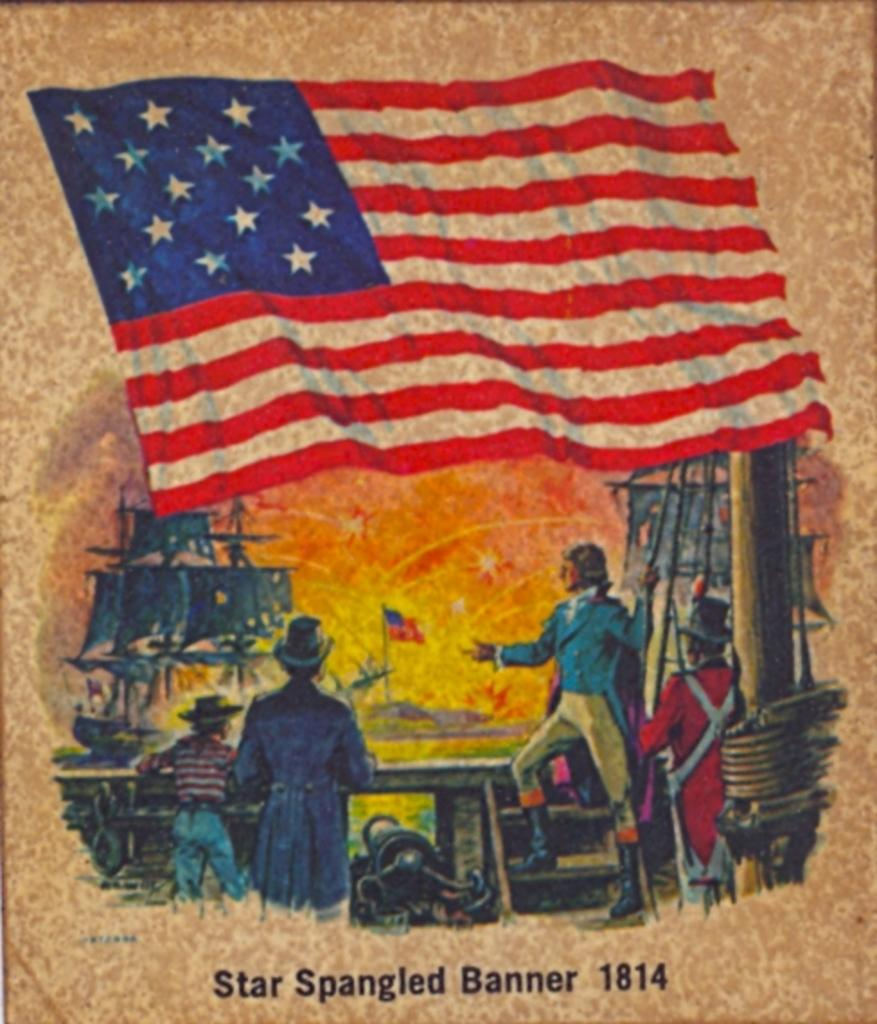What is the main subject in the center of the image? There is a poster in the center of the image. What can be seen on the poster? There are people depicted on the poster, along with flags and text. What type of spoon is being used to stir the moon in the image? There is no spoon or moon present in the image; it only features a poster with people, flags, and text. 